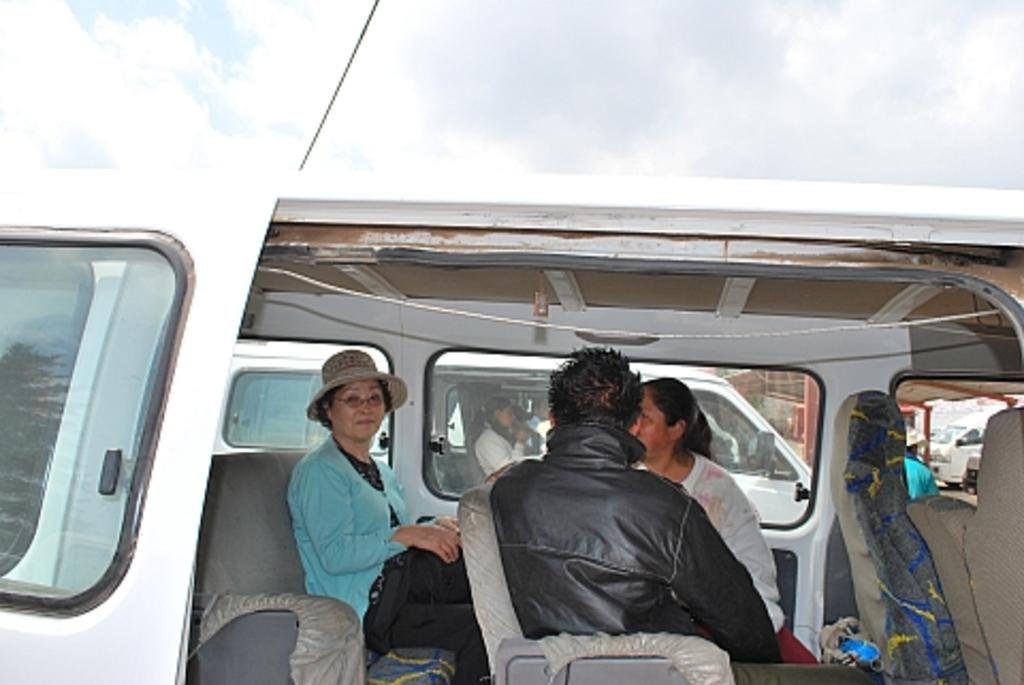What can be seen at the top of the image? The sky with clouds is visible at the top of the image. What are the people in the image doing? There are persons sitting inside a car. What type of window does the car have? The car has a glass window. What is visible through the car's glass window? Another vehicle is visible through the car's glass window. Can you describe the person inside the other vehicle? A person is sitting inside the other vehicle. What type of rhythm can be heard coming from the robin in the image? There is no robin present in the image, and therefore no rhythm can be heard. 